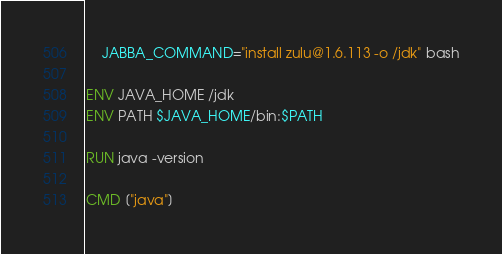Convert code to text. <code><loc_0><loc_0><loc_500><loc_500><_Dockerfile_>    JABBA_COMMAND="install zulu@1.6.113 -o /jdk" bash

ENV JAVA_HOME /jdk
ENV PATH $JAVA_HOME/bin:$PATH

RUN java -version

CMD ["java"]</code> 